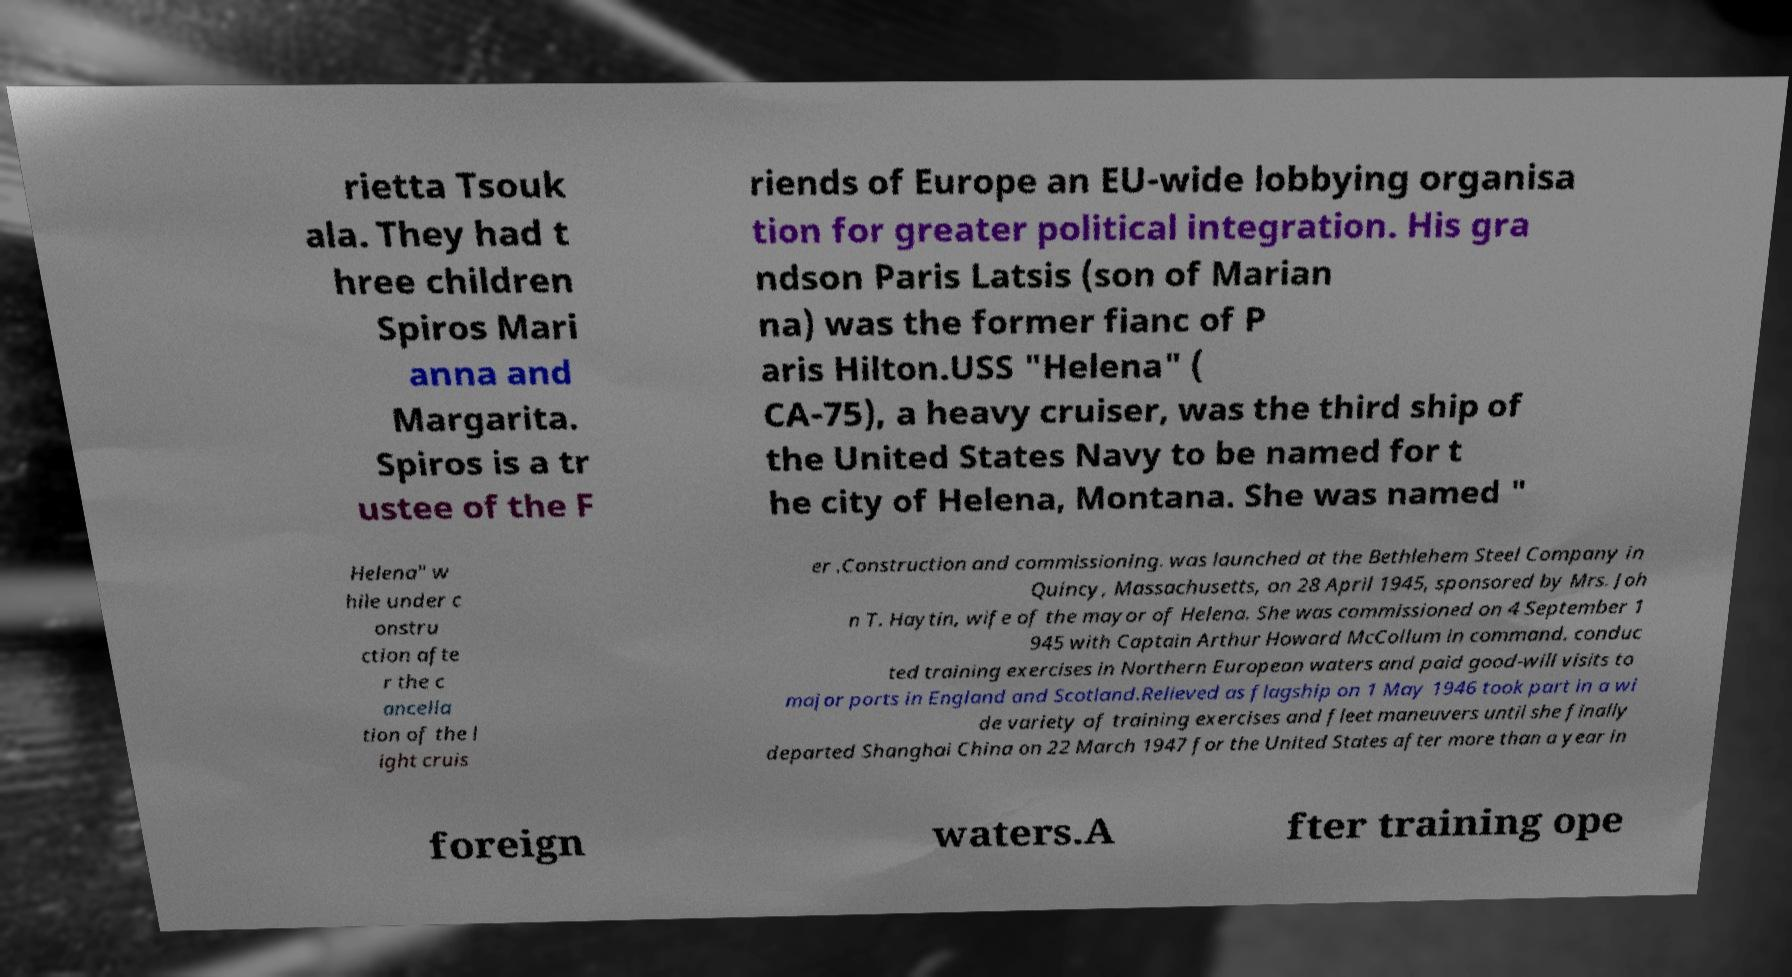I need the written content from this picture converted into text. Can you do that? rietta Tsouk ala. They had t hree children Spiros Mari anna and Margarita. Spiros is a tr ustee of the F riends of Europe an EU-wide lobbying organisa tion for greater political integration. His gra ndson Paris Latsis (son of Marian na) was the former fianc of P aris Hilton.USS "Helena" ( CA-75), a heavy cruiser, was the third ship of the United States Navy to be named for t he city of Helena, Montana. She was named " Helena" w hile under c onstru ction afte r the c ancella tion of the l ight cruis er .Construction and commissioning. was launched at the Bethlehem Steel Company in Quincy, Massachusetts, on 28 April 1945, sponsored by Mrs. Joh n T. Haytin, wife of the mayor of Helena. She was commissioned on 4 September 1 945 with Captain Arthur Howard McCollum in command. conduc ted training exercises in Northern European waters and paid good-will visits to major ports in England and Scotland.Relieved as flagship on 1 May 1946 took part in a wi de variety of training exercises and fleet maneuvers until she finally departed Shanghai China on 22 March 1947 for the United States after more than a year in foreign waters.A fter training ope 